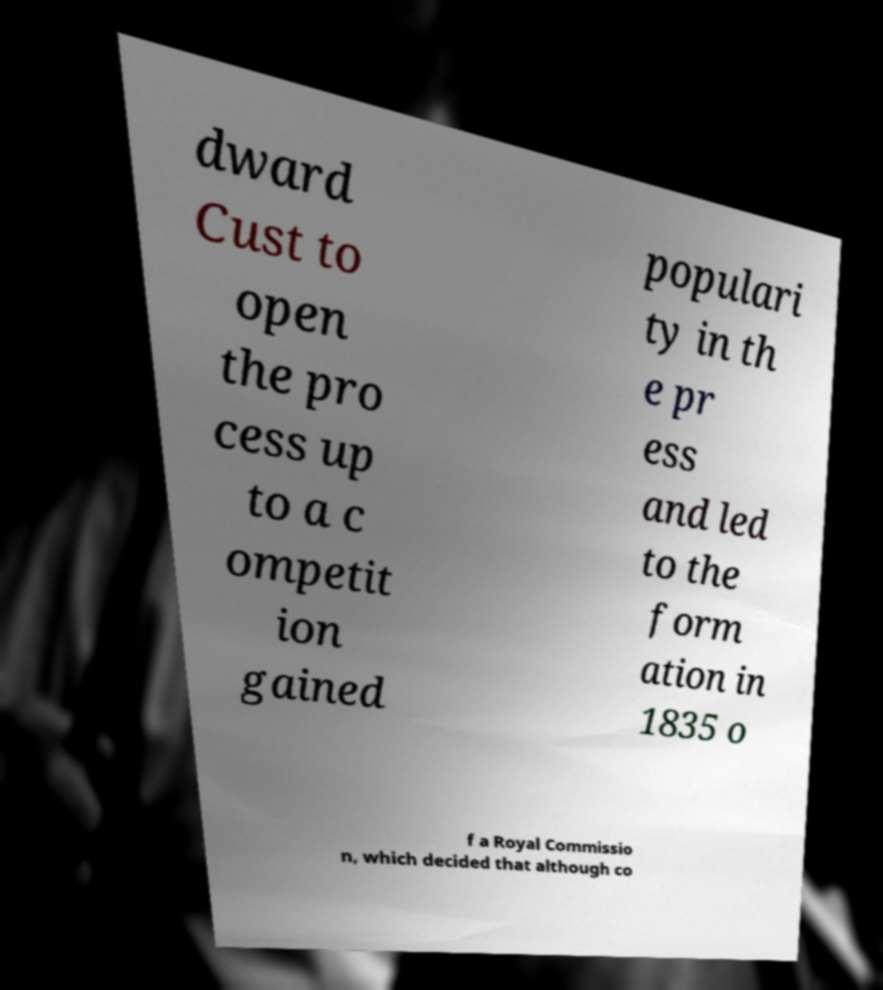For documentation purposes, I need the text within this image transcribed. Could you provide that? dward Cust to open the pro cess up to a c ompetit ion gained populari ty in th e pr ess and led to the form ation in 1835 o f a Royal Commissio n, which decided that although co 